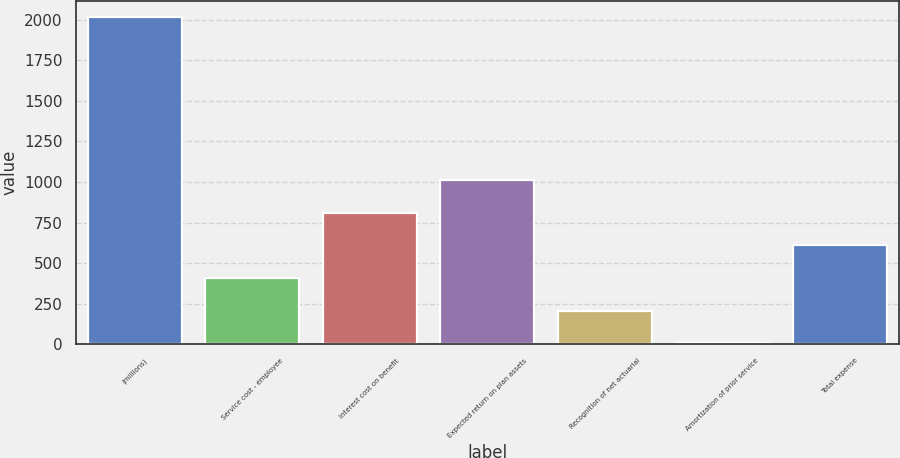Convert chart. <chart><loc_0><loc_0><loc_500><loc_500><bar_chart><fcel>(millions)<fcel>Service cost - employee<fcel>Interest cost on benefit<fcel>Expected return on plan assets<fcel>Recognition of net actuarial<fcel>Amortization of prior service<fcel>Total expense<nl><fcel>2015<fcel>408.52<fcel>810.14<fcel>1010.95<fcel>207.71<fcel>6.9<fcel>609.33<nl></chart> 